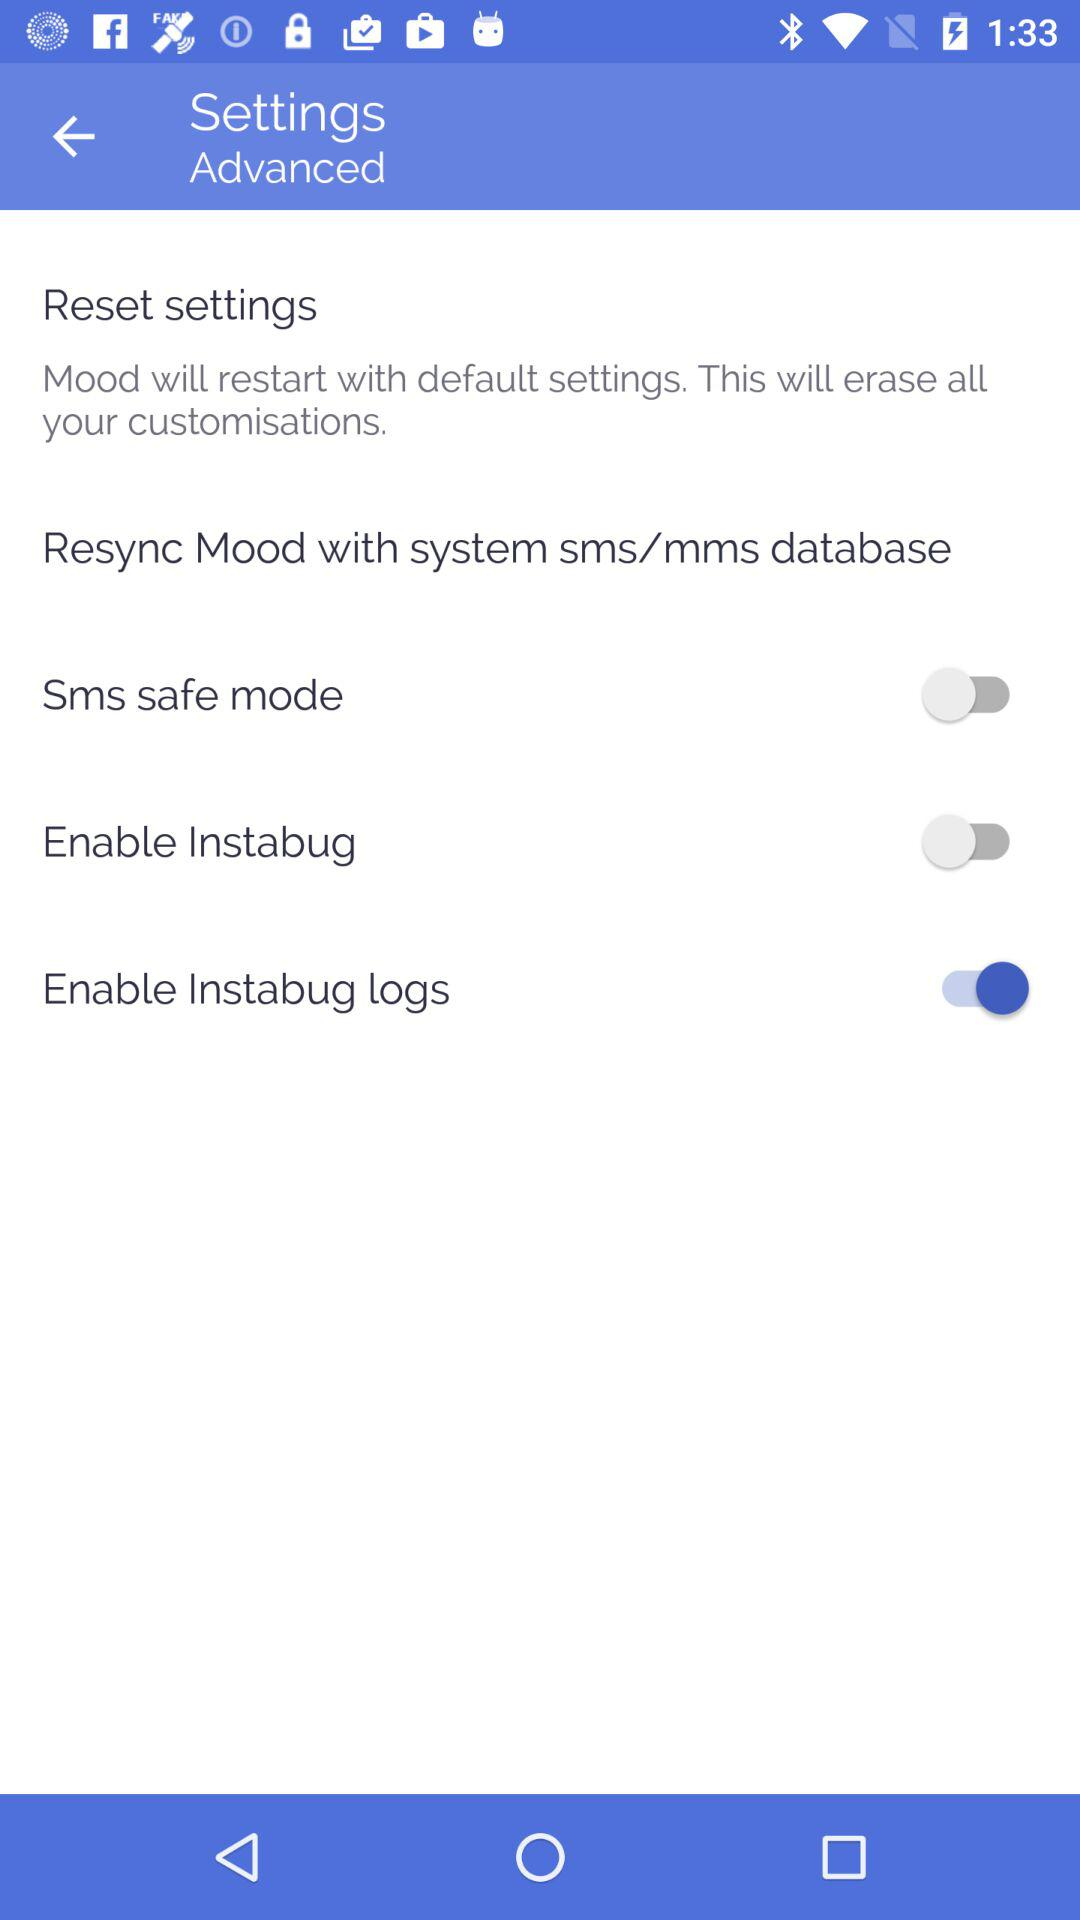What's the status of the "Enable Instabug logs"? The status of the "Enable Instabug logs" is "on". 